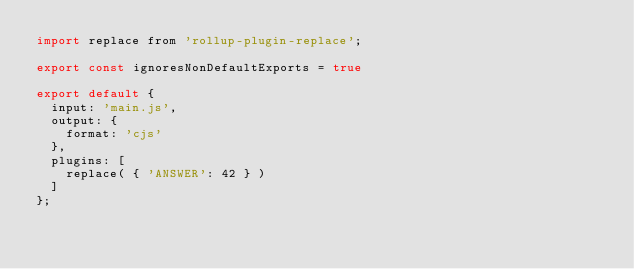<code> <loc_0><loc_0><loc_500><loc_500><_JavaScript_>import replace from 'rollup-plugin-replace';

export const ignoresNonDefaultExports = true

export default {
	input: 'main.js',
	output: {
		format: 'cjs'
	},
	plugins: [
		replace( { 'ANSWER': 42 } )
	]
};
</code> 